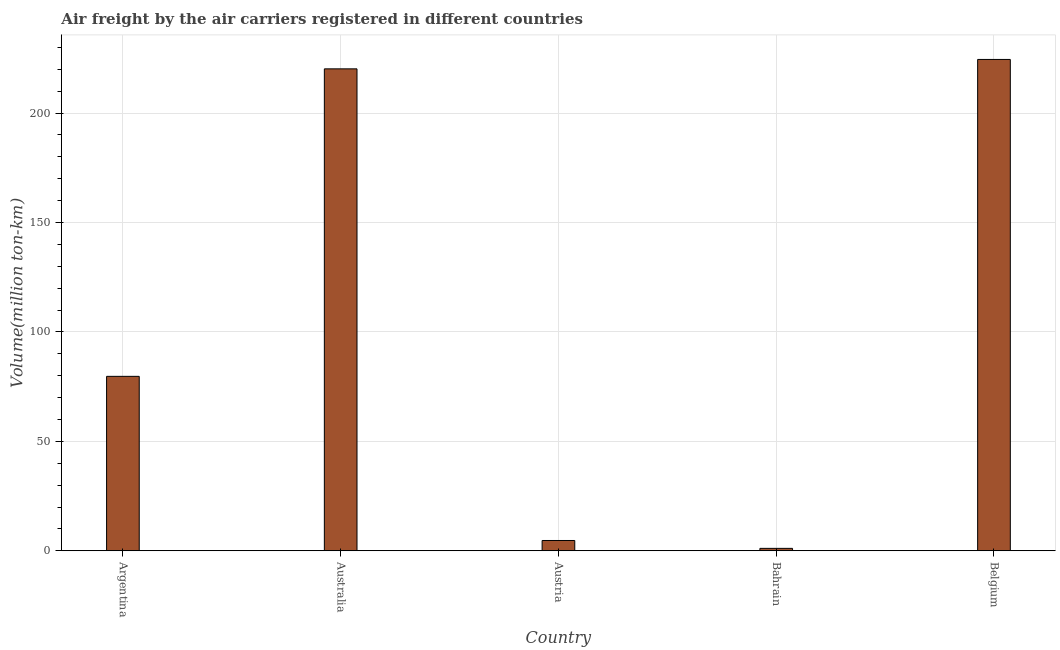Does the graph contain grids?
Give a very brief answer. Yes. What is the title of the graph?
Ensure brevity in your answer.  Air freight by the air carriers registered in different countries. What is the label or title of the X-axis?
Give a very brief answer. Country. What is the label or title of the Y-axis?
Offer a terse response. Volume(million ton-km). What is the air freight in Austria?
Keep it short and to the point. 4.7. Across all countries, what is the maximum air freight?
Provide a succinct answer. 224.5. Across all countries, what is the minimum air freight?
Make the answer very short. 1.1. In which country was the air freight maximum?
Ensure brevity in your answer.  Belgium. In which country was the air freight minimum?
Provide a short and direct response. Bahrain. What is the sum of the air freight?
Provide a short and direct response. 530.2. What is the average air freight per country?
Your answer should be compact. 106.04. What is the median air freight?
Provide a short and direct response. 79.7. What is the ratio of the air freight in Australia to that in Bahrain?
Give a very brief answer. 200.18. Is the air freight in Bahrain less than that in Belgium?
Your answer should be compact. Yes. Is the sum of the air freight in Austria and Belgium greater than the maximum air freight across all countries?
Offer a terse response. Yes. What is the difference between the highest and the lowest air freight?
Offer a terse response. 223.4. In how many countries, is the air freight greater than the average air freight taken over all countries?
Offer a very short reply. 2. How many bars are there?
Provide a short and direct response. 5. Are all the bars in the graph horizontal?
Keep it short and to the point. No. How many countries are there in the graph?
Provide a succinct answer. 5. What is the Volume(million ton-km) in Argentina?
Your answer should be very brief. 79.7. What is the Volume(million ton-km) of Australia?
Offer a very short reply. 220.2. What is the Volume(million ton-km) in Austria?
Offer a terse response. 4.7. What is the Volume(million ton-km) of Bahrain?
Your answer should be very brief. 1.1. What is the Volume(million ton-km) of Belgium?
Provide a short and direct response. 224.5. What is the difference between the Volume(million ton-km) in Argentina and Australia?
Your answer should be compact. -140.5. What is the difference between the Volume(million ton-km) in Argentina and Bahrain?
Your answer should be very brief. 78.6. What is the difference between the Volume(million ton-km) in Argentina and Belgium?
Make the answer very short. -144.8. What is the difference between the Volume(million ton-km) in Australia and Austria?
Offer a terse response. 215.5. What is the difference between the Volume(million ton-km) in Australia and Bahrain?
Ensure brevity in your answer.  219.1. What is the difference between the Volume(million ton-km) in Austria and Bahrain?
Provide a short and direct response. 3.6. What is the difference between the Volume(million ton-km) in Austria and Belgium?
Give a very brief answer. -219.8. What is the difference between the Volume(million ton-km) in Bahrain and Belgium?
Your answer should be very brief. -223.4. What is the ratio of the Volume(million ton-km) in Argentina to that in Australia?
Keep it short and to the point. 0.36. What is the ratio of the Volume(million ton-km) in Argentina to that in Austria?
Give a very brief answer. 16.96. What is the ratio of the Volume(million ton-km) in Argentina to that in Bahrain?
Ensure brevity in your answer.  72.45. What is the ratio of the Volume(million ton-km) in Argentina to that in Belgium?
Provide a succinct answer. 0.35. What is the ratio of the Volume(million ton-km) in Australia to that in Austria?
Offer a very short reply. 46.85. What is the ratio of the Volume(million ton-km) in Australia to that in Bahrain?
Your answer should be very brief. 200.18. What is the ratio of the Volume(million ton-km) in Austria to that in Bahrain?
Your response must be concise. 4.27. What is the ratio of the Volume(million ton-km) in Austria to that in Belgium?
Make the answer very short. 0.02. What is the ratio of the Volume(million ton-km) in Bahrain to that in Belgium?
Provide a succinct answer. 0.01. 